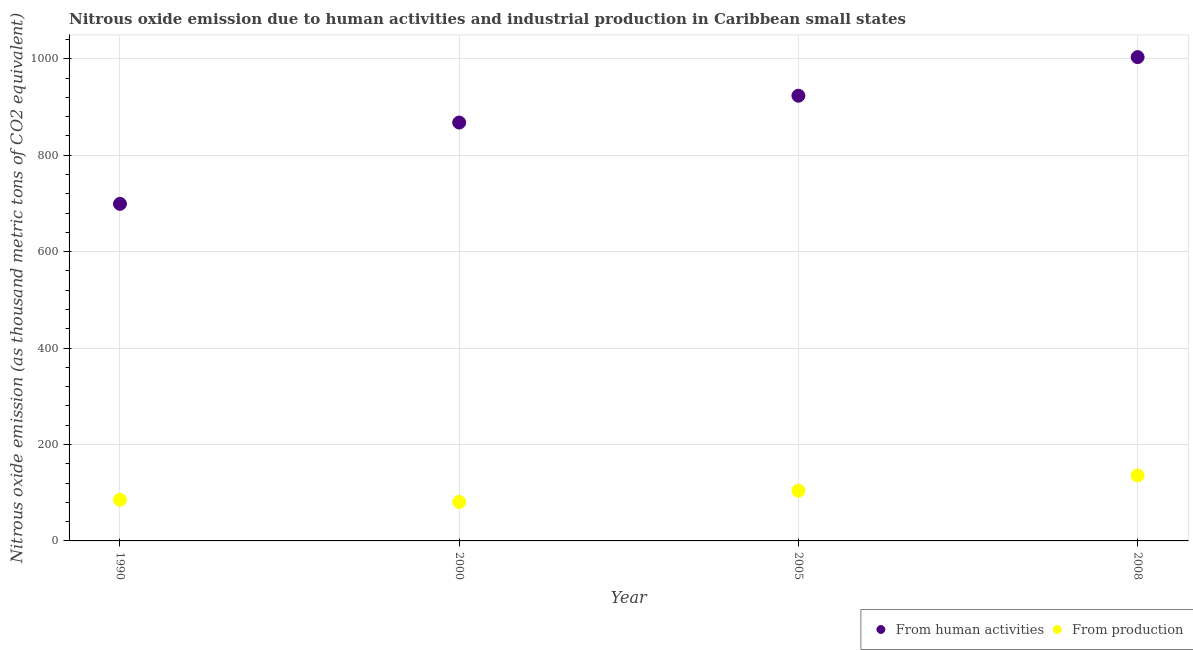How many different coloured dotlines are there?
Offer a very short reply. 2. What is the amount of emissions generated from industries in 2000?
Your response must be concise. 80.8. Across all years, what is the maximum amount of emissions generated from industries?
Ensure brevity in your answer.  135.8. Across all years, what is the minimum amount of emissions generated from industries?
Your answer should be compact. 80.8. In which year was the amount of emissions generated from industries maximum?
Provide a short and direct response. 2008. In which year was the amount of emissions generated from industries minimum?
Ensure brevity in your answer.  2000. What is the total amount of emissions from human activities in the graph?
Provide a short and direct response. 3493.5. What is the difference between the amount of emissions generated from industries in 1990 and that in 2005?
Provide a succinct answer. -18.8. What is the difference between the amount of emissions from human activities in 2008 and the amount of emissions generated from industries in 2005?
Provide a succinct answer. 899.2. What is the average amount of emissions generated from industries per year?
Provide a short and direct response. 101.55. In the year 2008, what is the difference between the amount of emissions from human activities and amount of emissions generated from industries?
Provide a succinct answer. 867.6. What is the ratio of the amount of emissions from human activities in 1990 to that in 2000?
Offer a very short reply. 0.81. What is the difference between the highest and the second highest amount of emissions generated from industries?
Offer a very short reply. 31.6. What is the difference between the highest and the lowest amount of emissions from human activities?
Offer a terse response. 304.3. In how many years, is the amount of emissions from human activities greater than the average amount of emissions from human activities taken over all years?
Make the answer very short. 2. Is the sum of the amount of emissions from human activities in 1990 and 2000 greater than the maximum amount of emissions generated from industries across all years?
Your answer should be very brief. Yes. Does the amount of emissions generated from industries monotonically increase over the years?
Your answer should be very brief. No. Is the amount of emissions from human activities strictly less than the amount of emissions generated from industries over the years?
Offer a terse response. No. How many dotlines are there?
Ensure brevity in your answer.  2. How many years are there in the graph?
Your answer should be very brief. 4. Where does the legend appear in the graph?
Provide a short and direct response. Bottom right. What is the title of the graph?
Offer a terse response. Nitrous oxide emission due to human activities and industrial production in Caribbean small states. What is the label or title of the X-axis?
Your answer should be very brief. Year. What is the label or title of the Y-axis?
Provide a succinct answer. Nitrous oxide emission (as thousand metric tons of CO2 equivalent). What is the Nitrous oxide emission (as thousand metric tons of CO2 equivalent) of From human activities in 1990?
Make the answer very short. 699.1. What is the Nitrous oxide emission (as thousand metric tons of CO2 equivalent) of From production in 1990?
Your response must be concise. 85.4. What is the Nitrous oxide emission (as thousand metric tons of CO2 equivalent) in From human activities in 2000?
Offer a terse response. 867.7. What is the Nitrous oxide emission (as thousand metric tons of CO2 equivalent) in From production in 2000?
Provide a short and direct response. 80.8. What is the Nitrous oxide emission (as thousand metric tons of CO2 equivalent) in From human activities in 2005?
Your response must be concise. 923.3. What is the Nitrous oxide emission (as thousand metric tons of CO2 equivalent) in From production in 2005?
Keep it short and to the point. 104.2. What is the Nitrous oxide emission (as thousand metric tons of CO2 equivalent) of From human activities in 2008?
Ensure brevity in your answer.  1003.4. What is the Nitrous oxide emission (as thousand metric tons of CO2 equivalent) in From production in 2008?
Keep it short and to the point. 135.8. Across all years, what is the maximum Nitrous oxide emission (as thousand metric tons of CO2 equivalent) of From human activities?
Make the answer very short. 1003.4. Across all years, what is the maximum Nitrous oxide emission (as thousand metric tons of CO2 equivalent) in From production?
Your answer should be very brief. 135.8. Across all years, what is the minimum Nitrous oxide emission (as thousand metric tons of CO2 equivalent) in From human activities?
Offer a very short reply. 699.1. Across all years, what is the minimum Nitrous oxide emission (as thousand metric tons of CO2 equivalent) in From production?
Ensure brevity in your answer.  80.8. What is the total Nitrous oxide emission (as thousand metric tons of CO2 equivalent) in From human activities in the graph?
Offer a terse response. 3493.5. What is the total Nitrous oxide emission (as thousand metric tons of CO2 equivalent) of From production in the graph?
Keep it short and to the point. 406.2. What is the difference between the Nitrous oxide emission (as thousand metric tons of CO2 equivalent) in From human activities in 1990 and that in 2000?
Offer a very short reply. -168.6. What is the difference between the Nitrous oxide emission (as thousand metric tons of CO2 equivalent) in From production in 1990 and that in 2000?
Provide a short and direct response. 4.6. What is the difference between the Nitrous oxide emission (as thousand metric tons of CO2 equivalent) in From human activities in 1990 and that in 2005?
Your answer should be compact. -224.2. What is the difference between the Nitrous oxide emission (as thousand metric tons of CO2 equivalent) in From production in 1990 and that in 2005?
Your answer should be compact. -18.8. What is the difference between the Nitrous oxide emission (as thousand metric tons of CO2 equivalent) of From human activities in 1990 and that in 2008?
Ensure brevity in your answer.  -304.3. What is the difference between the Nitrous oxide emission (as thousand metric tons of CO2 equivalent) in From production in 1990 and that in 2008?
Offer a very short reply. -50.4. What is the difference between the Nitrous oxide emission (as thousand metric tons of CO2 equivalent) in From human activities in 2000 and that in 2005?
Offer a very short reply. -55.6. What is the difference between the Nitrous oxide emission (as thousand metric tons of CO2 equivalent) of From production in 2000 and that in 2005?
Offer a very short reply. -23.4. What is the difference between the Nitrous oxide emission (as thousand metric tons of CO2 equivalent) of From human activities in 2000 and that in 2008?
Make the answer very short. -135.7. What is the difference between the Nitrous oxide emission (as thousand metric tons of CO2 equivalent) in From production in 2000 and that in 2008?
Your response must be concise. -55. What is the difference between the Nitrous oxide emission (as thousand metric tons of CO2 equivalent) of From human activities in 2005 and that in 2008?
Make the answer very short. -80.1. What is the difference between the Nitrous oxide emission (as thousand metric tons of CO2 equivalent) of From production in 2005 and that in 2008?
Your answer should be compact. -31.6. What is the difference between the Nitrous oxide emission (as thousand metric tons of CO2 equivalent) in From human activities in 1990 and the Nitrous oxide emission (as thousand metric tons of CO2 equivalent) in From production in 2000?
Make the answer very short. 618.3. What is the difference between the Nitrous oxide emission (as thousand metric tons of CO2 equivalent) of From human activities in 1990 and the Nitrous oxide emission (as thousand metric tons of CO2 equivalent) of From production in 2005?
Give a very brief answer. 594.9. What is the difference between the Nitrous oxide emission (as thousand metric tons of CO2 equivalent) of From human activities in 1990 and the Nitrous oxide emission (as thousand metric tons of CO2 equivalent) of From production in 2008?
Offer a very short reply. 563.3. What is the difference between the Nitrous oxide emission (as thousand metric tons of CO2 equivalent) of From human activities in 2000 and the Nitrous oxide emission (as thousand metric tons of CO2 equivalent) of From production in 2005?
Provide a short and direct response. 763.5. What is the difference between the Nitrous oxide emission (as thousand metric tons of CO2 equivalent) in From human activities in 2000 and the Nitrous oxide emission (as thousand metric tons of CO2 equivalent) in From production in 2008?
Make the answer very short. 731.9. What is the difference between the Nitrous oxide emission (as thousand metric tons of CO2 equivalent) in From human activities in 2005 and the Nitrous oxide emission (as thousand metric tons of CO2 equivalent) in From production in 2008?
Your answer should be very brief. 787.5. What is the average Nitrous oxide emission (as thousand metric tons of CO2 equivalent) in From human activities per year?
Ensure brevity in your answer.  873.38. What is the average Nitrous oxide emission (as thousand metric tons of CO2 equivalent) in From production per year?
Provide a short and direct response. 101.55. In the year 1990, what is the difference between the Nitrous oxide emission (as thousand metric tons of CO2 equivalent) of From human activities and Nitrous oxide emission (as thousand metric tons of CO2 equivalent) of From production?
Ensure brevity in your answer.  613.7. In the year 2000, what is the difference between the Nitrous oxide emission (as thousand metric tons of CO2 equivalent) in From human activities and Nitrous oxide emission (as thousand metric tons of CO2 equivalent) in From production?
Your answer should be compact. 786.9. In the year 2005, what is the difference between the Nitrous oxide emission (as thousand metric tons of CO2 equivalent) of From human activities and Nitrous oxide emission (as thousand metric tons of CO2 equivalent) of From production?
Provide a short and direct response. 819.1. In the year 2008, what is the difference between the Nitrous oxide emission (as thousand metric tons of CO2 equivalent) in From human activities and Nitrous oxide emission (as thousand metric tons of CO2 equivalent) in From production?
Provide a succinct answer. 867.6. What is the ratio of the Nitrous oxide emission (as thousand metric tons of CO2 equivalent) of From human activities in 1990 to that in 2000?
Keep it short and to the point. 0.81. What is the ratio of the Nitrous oxide emission (as thousand metric tons of CO2 equivalent) in From production in 1990 to that in 2000?
Make the answer very short. 1.06. What is the ratio of the Nitrous oxide emission (as thousand metric tons of CO2 equivalent) in From human activities in 1990 to that in 2005?
Provide a short and direct response. 0.76. What is the ratio of the Nitrous oxide emission (as thousand metric tons of CO2 equivalent) in From production in 1990 to that in 2005?
Provide a short and direct response. 0.82. What is the ratio of the Nitrous oxide emission (as thousand metric tons of CO2 equivalent) of From human activities in 1990 to that in 2008?
Provide a succinct answer. 0.7. What is the ratio of the Nitrous oxide emission (as thousand metric tons of CO2 equivalent) in From production in 1990 to that in 2008?
Provide a succinct answer. 0.63. What is the ratio of the Nitrous oxide emission (as thousand metric tons of CO2 equivalent) of From human activities in 2000 to that in 2005?
Your response must be concise. 0.94. What is the ratio of the Nitrous oxide emission (as thousand metric tons of CO2 equivalent) in From production in 2000 to that in 2005?
Make the answer very short. 0.78. What is the ratio of the Nitrous oxide emission (as thousand metric tons of CO2 equivalent) of From human activities in 2000 to that in 2008?
Your response must be concise. 0.86. What is the ratio of the Nitrous oxide emission (as thousand metric tons of CO2 equivalent) of From production in 2000 to that in 2008?
Offer a terse response. 0.59. What is the ratio of the Nitrous oxide emission (as thousand metric tons of CO2 equivalent) of From human activities in 2005 to that in 2008?
Provide a short and direct response. 0.92. What is the ratio of the Nitrous oxide emission (as thousand metric tons of CO2 equivalent) in From production in 2005 to that in 2008?
Offer a terse response. 0.77. What is the difference between the highest and the second highest Nitrous oxide emission (as thousand metric tons of CO2 equivalent) in From human activities?
Offer a terse response. 80.1. What is the difference between the highest and the second highest Nitrous oxide emission (as thousand metric tons of CO2 equivalent) of From production?
Your answer should be compact. 31.6. What is the difference between the highest and the lowest Nitrous oxide emission (as thousand metric tons of CO2 equivalent) in From human activities?
Offer a very short reply. 304.3. What is the difference between the highest and the lowest Nitrous oxide emission (as thousand metric tons of CO2 equivalent) in From production?
Make the answer very short. 55. 